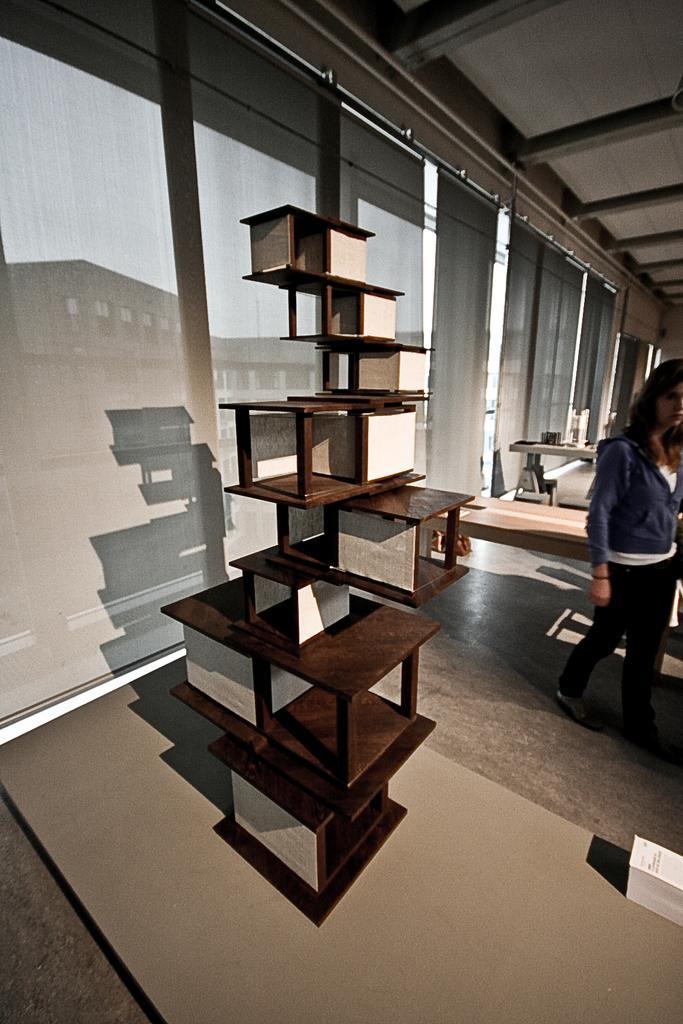Could you give a brief overview of what you see in this image? This image is clicked inside. There are tables. There is a woman standing in the right side, she is wearing blue and black dress. In the right side bottom corner there are some papers. In the middle there is something which is made of wood. 